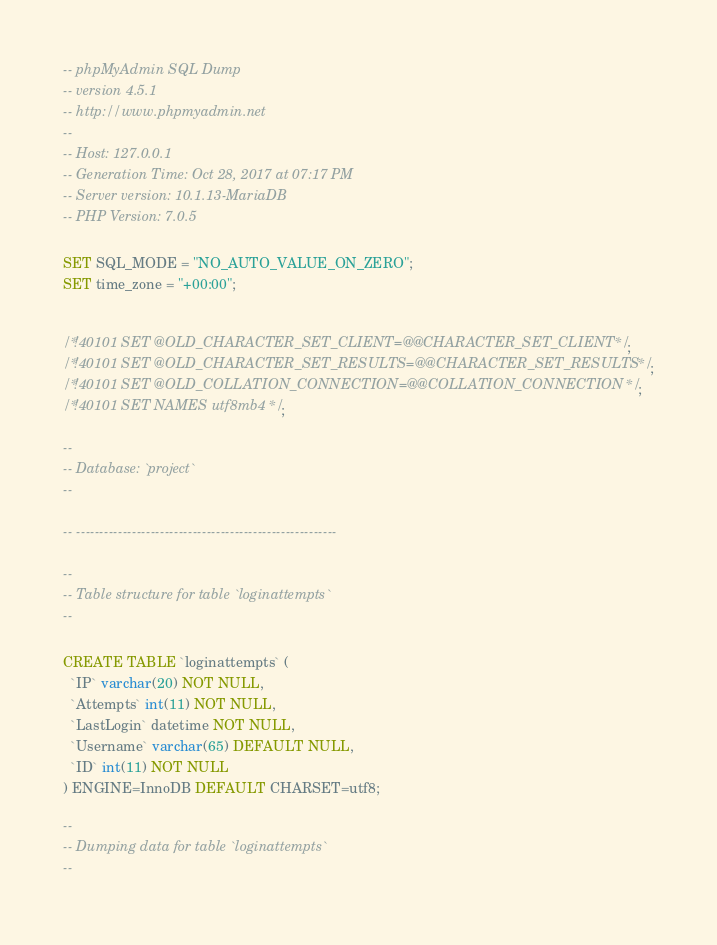Convert code to text. <code><loc_0><loc_0><loc_500><loc_500><_SQL_>-- phpMyAdmin SQL Dump
-- version 4.5.1
-- http://www.phpmyadmin.net
--
-- Host: 127.0.0.1
-- Generation Time: Oct 28, 2017 at 07:17 PM
-- Server version: 10.1.13-MariaDB
-- PHP Version: 7.0.5

SET SQL_MODE = "NO_AUTO_VALUE_ON_ZERO";
SET time_zone = "+00:00";


/*!40101 SET @OLD_CHARACTER_SET_CLIENT=@@CHARACTER_SET_CLIENT */;
/*!40101 SET @OLD_CHARACTER_SET_RESULTS=@@CHARACTER_SET_RESULTS */;
/*!40101 SET @OLD_COLLATION_CONNECTION=@@COLLATION_CONNECTION */;
/*!40101 SET NAMES utf8mb4 */;

--
-- Database: `project`
--

-- --------------------------------------------------------

--
-- Table structure for table `loginattempts`
--

CREATE TABLE `loginattempts` (
  `IP` varchar(20) NOT NULL,
  `Attempts` int(11) NOT NULL,
  `LastLogin` datetime NOT NULL,
  `Username` varchar(65) DEFAULT NULL,
  `ID` int(11) NOT NULL
) ENGINE=InnoDB DEFAULT CHARSET=utf8;

--
-- Dumping data for table `loginattempts`
--
</code> 